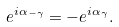<formula> <loc_0><loc_0><loc_500><loc_500>e ^ { i \alpha _ { - \gamma } } = - e ^ { i \alpha _ { \gamma } } .</formula> 